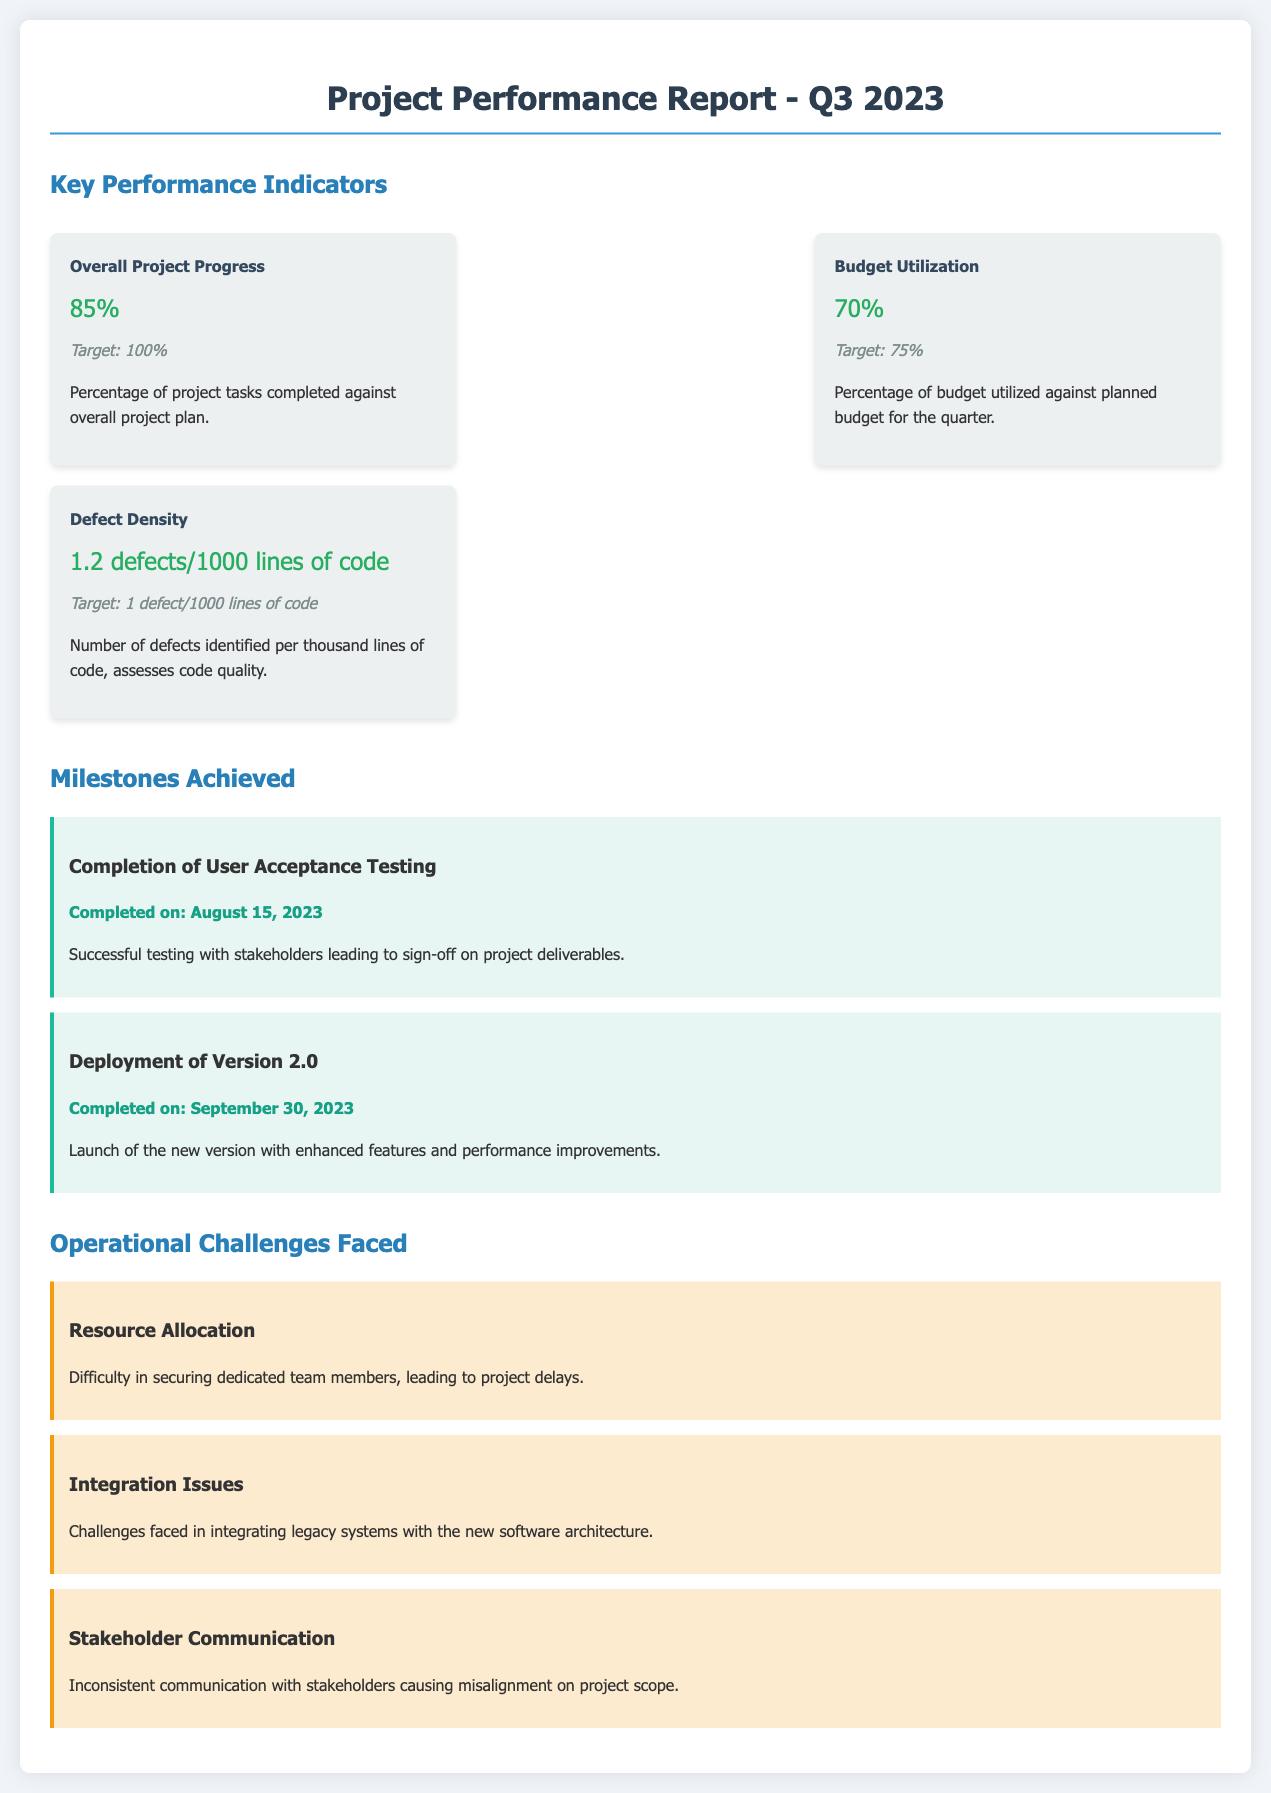What is the overall project progress? The overall project progress is the percentage of project tasks completed against the overall project plan.
Answer: 85% What is the target for budget utilization? The target for budget utilization is the planned percentage of the budget to be utilized for the quarter.
Answer: 75% What was completed on August 15, 2023? This date marks the completion of a significant milestone documented in the report.
Answer: User Acceptance Testing How many defects were identified per thousand lines of code? The defect density metric quantifies code quality by reporting defects per 1000 lines of code.
Answer: 1.2 defects/1000 lines of code What is one operational challenge faced by the project? This challenge denotes a significant issue affecting project performance and outcomes.
Answer: Resource Allocation What milestone was achieved on September 30, 2023? This milestone signifies an important phase in the project's timeline related to product delivery.
Answer: Deployment of Version 2.0 What does the defect density assess? This metric provides insight into a specific aspect of software quality in the project.
Answer: Code quality What percentage of project tasks was completed against the overall project plan? This statistic indicates the proportion of successful task completion in the project timeline.
Answer: 85% 